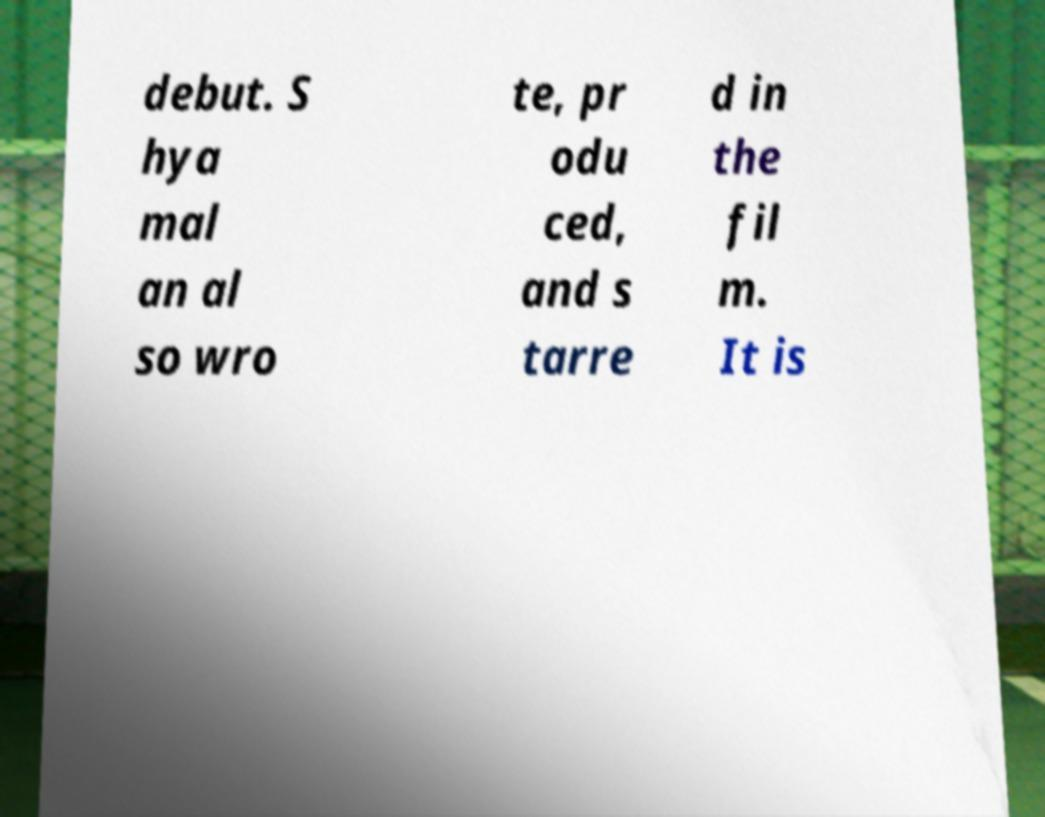What messages or text are displayed in this image? I need them in a readable, typed format. debut. S hya mal an al so wro te, pr odu ced, and s tarre d in the fil m. It is 